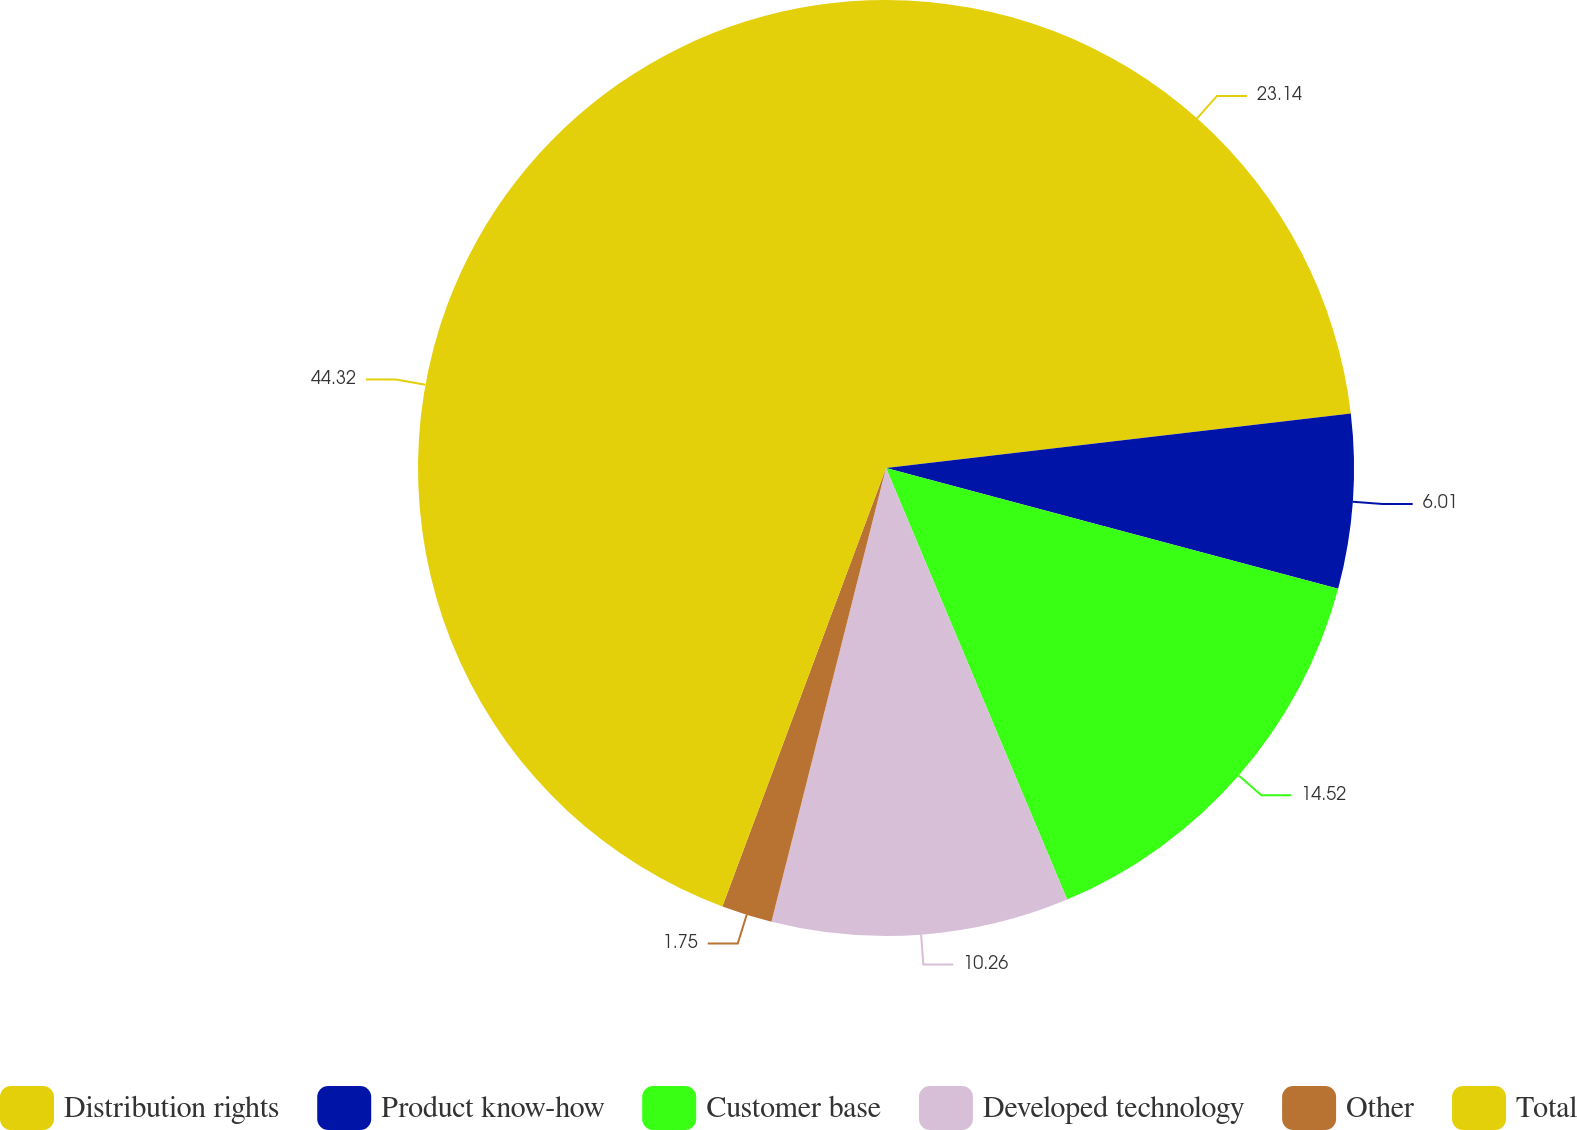Convert chart. <chart><loc_0><loc_0><loc_500><loc_500><pie_chart><fcel>Distribution rights<fcel>Product know-how<fcel>Customer base<fcel>Developed technology<fcel>Other<fcel>Total<nl><fcel>23.14%<fcel>6.01%<fcel>14.52%<fcel>10.26%<fcel>1.75%<fcel>44.31%<nl></chart> 